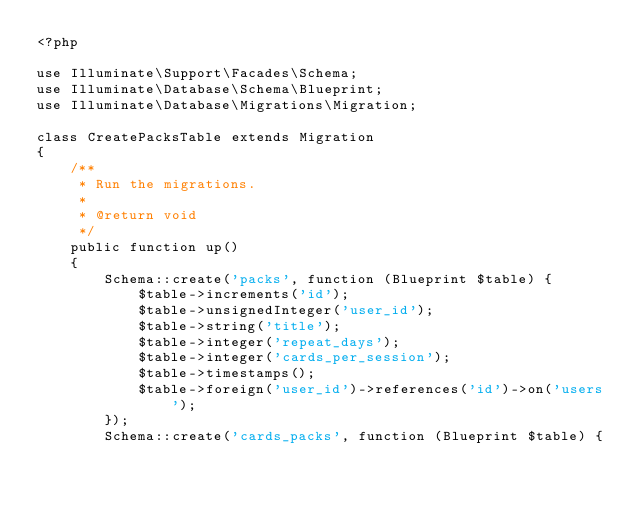<code> <loc_0><loc_0><loc_500><loc_500><_PHP_><?php

use Illuminate\Support\Facades\Schema;
use Illuminate\Database\Schema\Blueprint;
use Illuminate\Database\Migrations\Migration;

class CreatePacksTable extends Migration
{
    /**
     * Run the migrations.
     *
     * @return void
     */
    public function up()
    {
        Schema::create('packs', function (Blueprint $table) {
            $table->increments('id');
            $table->unsignedInteger('user_id');
            $table->string('title');
            $table->integer('repeat_days');
            $table->integer('cards_per_session');
            $table->timestamps();
            $table->foreign('user_id')->references('id')->on('users');
        });
        Schema::create('cards_packs', function (Blueprint $table) {</code> 